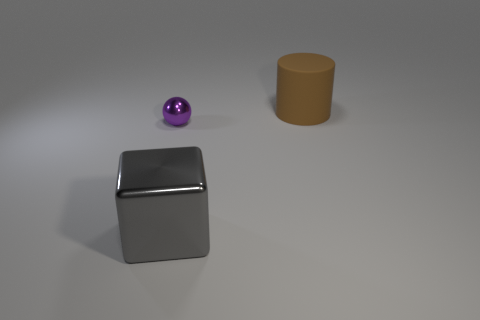There is a object that is both right of the small purple object and behind the large gray block; what size is it?
Provide a succinct answer. Large. What number of small brown shiny cubes are there?
Your response must be concise. 0. There is a cube that is the same size as the matte cylinder; what material is it?
Your answer should be compact. Metal. Are there any other balls that have the same size as the purple metal ball?
Offer a very short reply. No. What number of shiny things are either small green balls or large brown cylinders?
Keep it short and to the point. 0. There is a large object left of the big rubber cylinder that is on the right side of the big gray object; what number of brown matte things are to the right of it?
Keep it short and to the point. 1. There is a gray thing that is the same material as the tiny ball; what is its size?
Ensure brevity in your answer.  Large. Does the object to the right of the gray metal cube have the same size as the cube?
Your answer should be very brief. Yes. The object that is in front of the large brown matte thing and behind the large metal block is what color?
Give a very brief answer. Purple. How many objects are either large brown matte objects or large objects that are left of the matte object?
Ensure brevity in your answer.  2. 